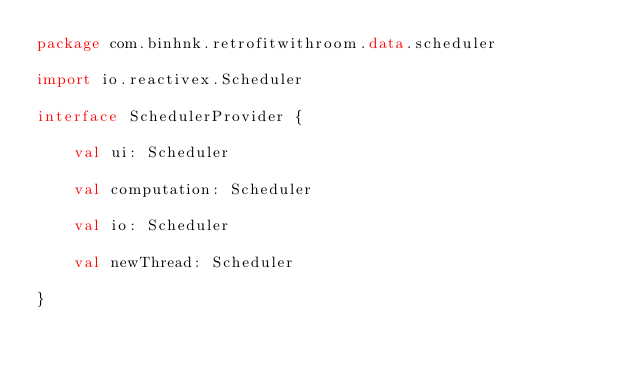<code> <loc_0><loc_0><loc_500><loc_500><_Kotlin_>package com.binhnk.retrofitwithroom.data.scheduler

import io.reactivex.Scheduler

interface SchedulerProvider {

    val ui: Scheduler

    val computation: Scheduler

    val io: Scheduler

    val newThread: Scheduler

}</code> 